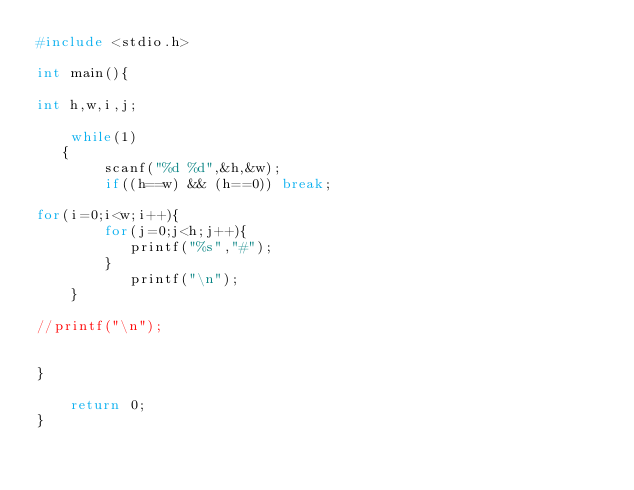<code> <loc_0><loc_0><loc_500><loc_500><_C_>#include <stdio.h>

int main(){

int h,w,i,j;

    while(1)
   {
        scanf("%d %d",&h,&w);
        if((h==w) && (h==0)) break;
        
for(i=0;i<w;i++){
        for(j=0;j<h;j++){
           printf("%s","#");
        }
           printf("\n");         
    }

//printf("\n");         


}
 
    return 0;
}</code> 